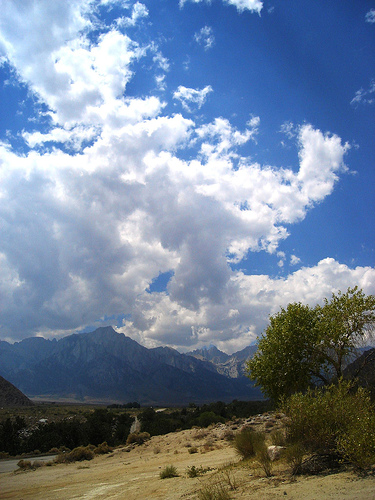<image>
Is there a rock under the tree? Yes. The rock is positioned underneath the tree, with the tree above it in the vertical space. Where is the sky in relation to the mountain? Is it behind the mountain? Yes. From this viewpoint, the sky is positioned behind the mountain, with the mountain partially or fully occluding the sky. Where is the sky in relation to the tree? Is it to the left of the tree? No. The sky is not to the left of the tree. From this viewpoint, they have a different horizontal relationship. 